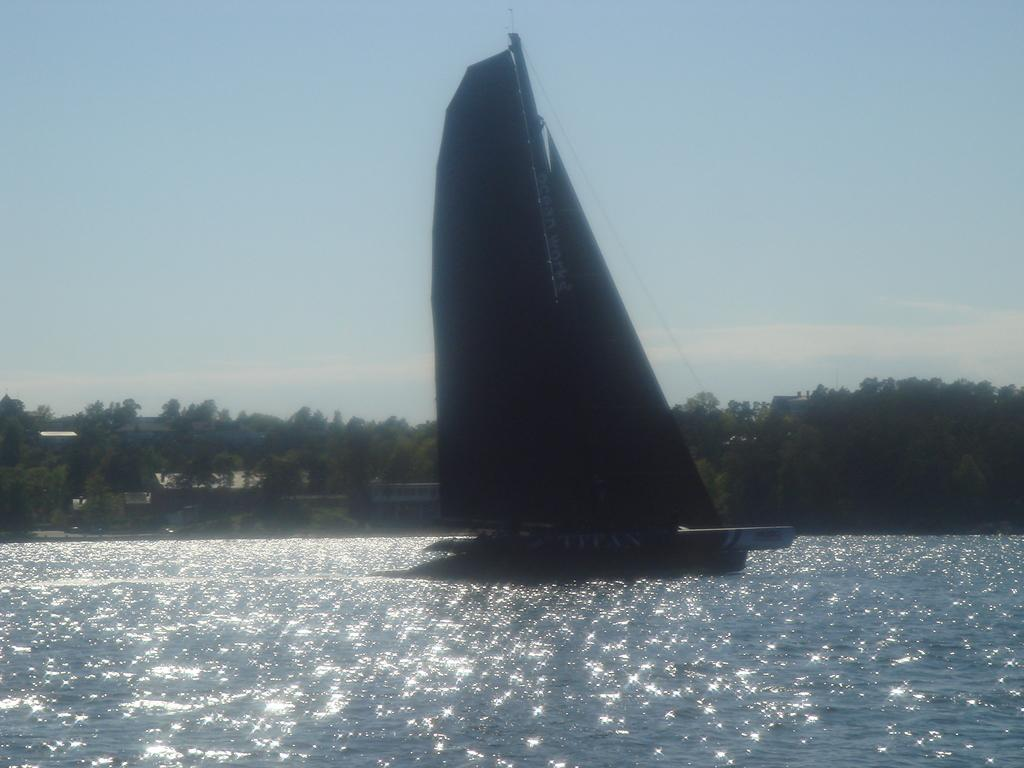What is the main subject of the image? The main subject of the image is a boat. What feature can be seen on the boat? The boat has a mast. Where is the boat located? The boat is on the water. What can be seen in the background of the image? There are trees, plants, and clouds in the blue sky in the background of the image. What type of vase can be seen resting on the boat in the image? There is no vase present in the image; the boat has a mast and is on the water. How does the boat shake in the image? The boat does not shake in the image; it is stationary on the water. 